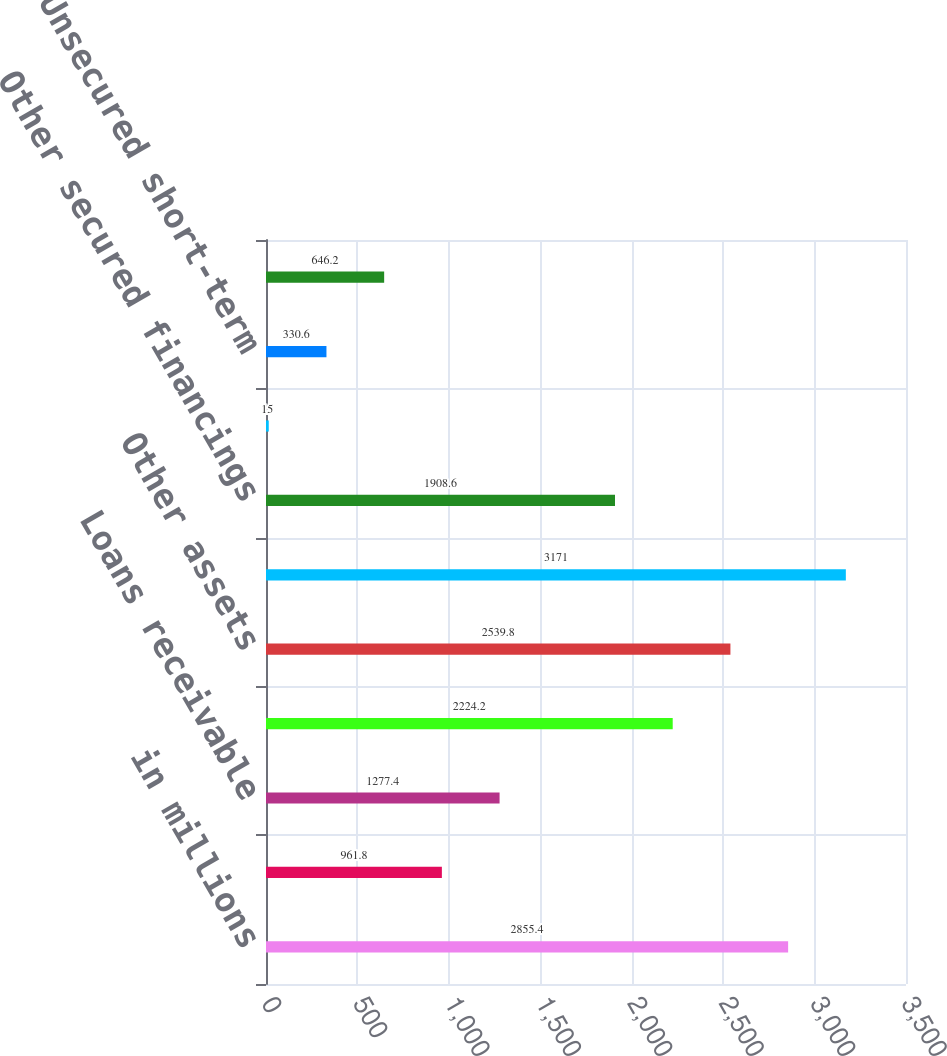Convert chart. <chart><loc_0><loc_0><loc_500><loc_500><bar_chart><fcel>in millions<fcel>Cash and cash equivalents<fcel>Loans receivable<fcel>Financial instruments owned<fcel>Other assets<fcel>Total<fcel>Other secured financings<fcel>Financial instruments sold but<fcel>Unsecured short-term<fcel>Unsecured long-term borrowings<nl><fcel>2855.4<fcel>961.8<fcel>1277.4<fcel>2224.2<fcel>2539.8<fcel>3171<fcel>1908.6<fcel>15<fcel>330.6<fcel>646.2<nl></chart> 